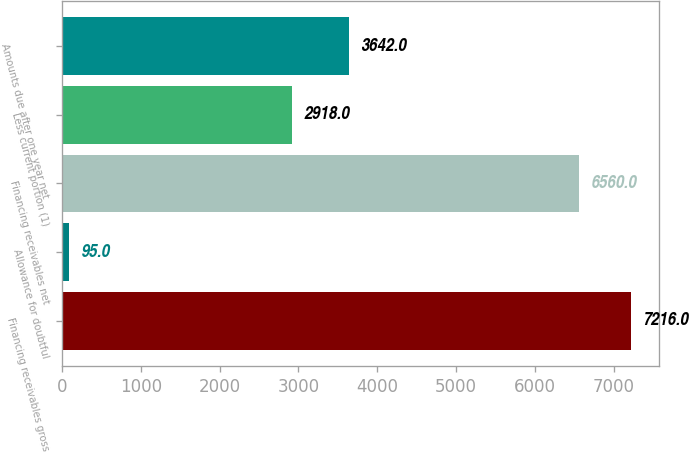<chart> <loc_0><loc_0><loc_500><loc_500><bar_chart><fcel>Financing receivables gross<fcel>Allowance for doubtful<fcel>Financing receivables net<fcel>Less current portion (1)<fcel>Amounts due after one year net<nl><fcel>7216<fcel>95<fcel>6560<fcel>2918<fcel>3642<nl></chart> 